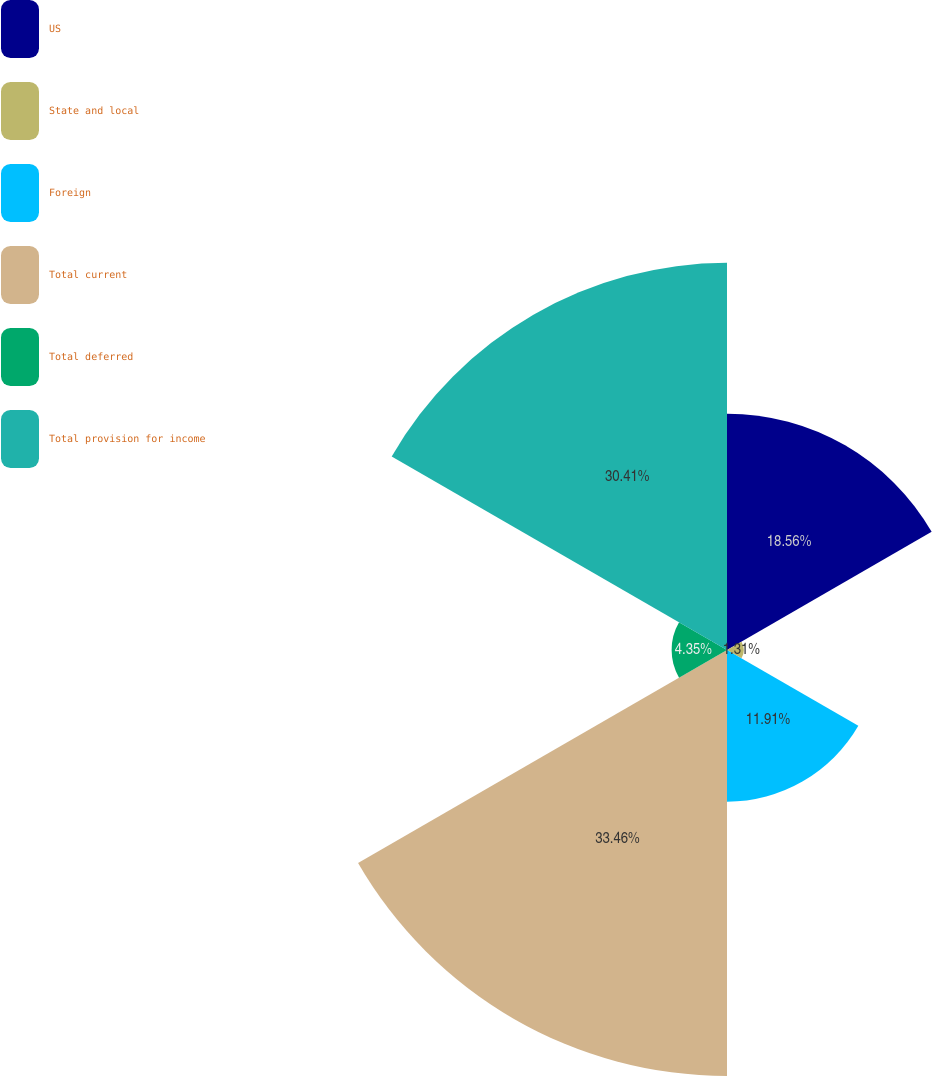<chart> <loc_0><loc_0><loc_500><loc_500><pie_chart><fcel>US<fcel>State and local<fcel>Foreign<fcel>Total current<fcel>Total deferred<fcel>Total provision for income<nl><fcel>18.56%<fcel>1.31%<fcel>11.91%<fcel>33.46%<fcel>4.35%<fcel>30.41%<nl></chart> 